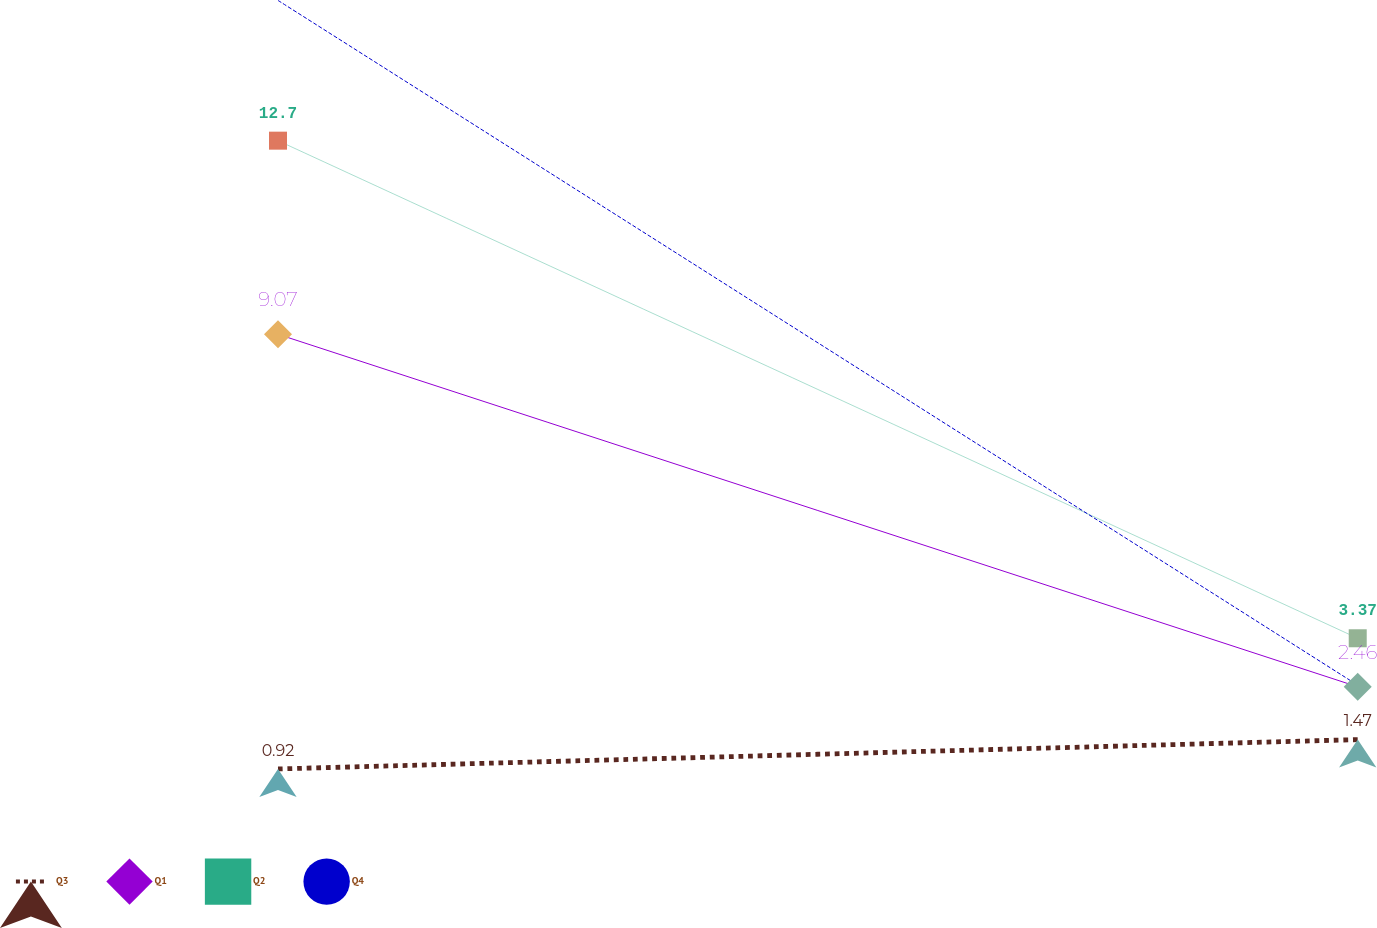Convert chart to OTSL. <chart><loc_0><loc_0><loc_500><loc_500><line_chart><ecel><fcel>Q3<fcel>Q1<fcel>Q2<fcel>Q4<nl><fcel>1828.92<fcel>0.92<fcel>9.07<fcel>12.7<fcel>15.33<nl><fcel>2204.52<fcel>1.47<fcel>2.46<fcel>3.37<fcel>2.49<nl><fcel>2274.19<fcel>6.45<fcel>0<fcel>4.3<fcel>5.62<nl></chart> 